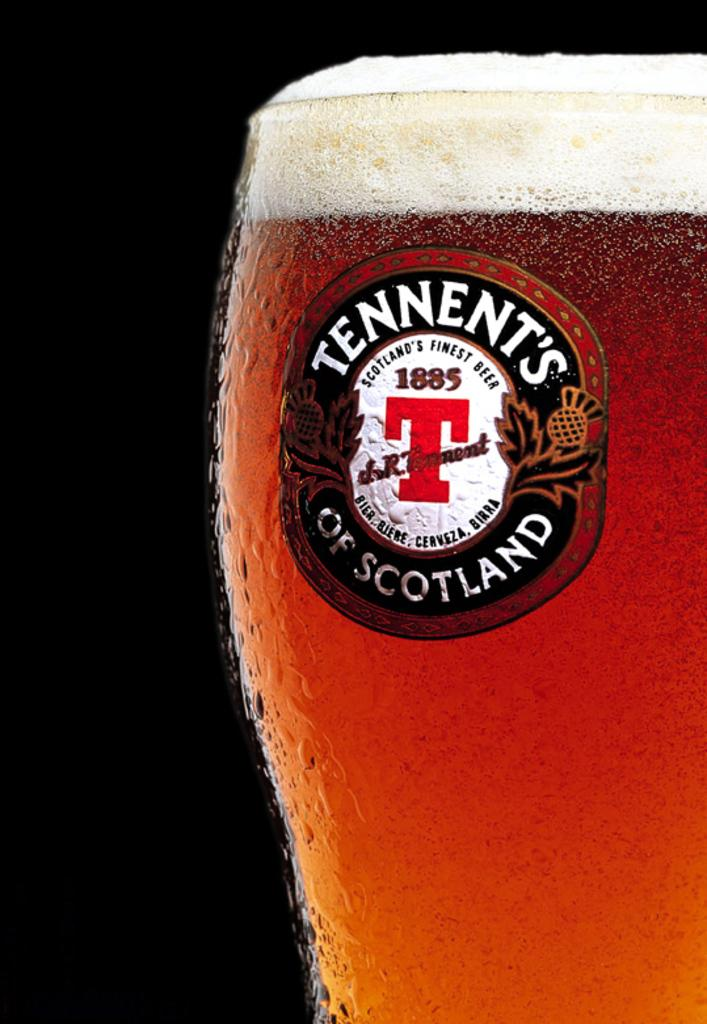<image>
Share a concise interpretation of the image provided. A mug of been with the words Tennent's of Scotland on the label. 